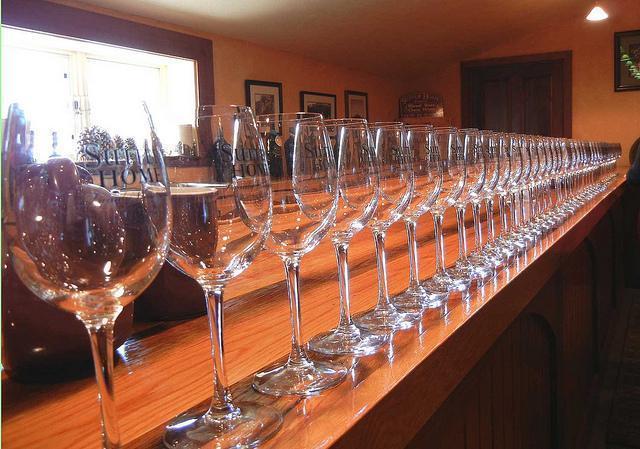How many wine glasses are in the photo?
Give a very brief answer. 8. 